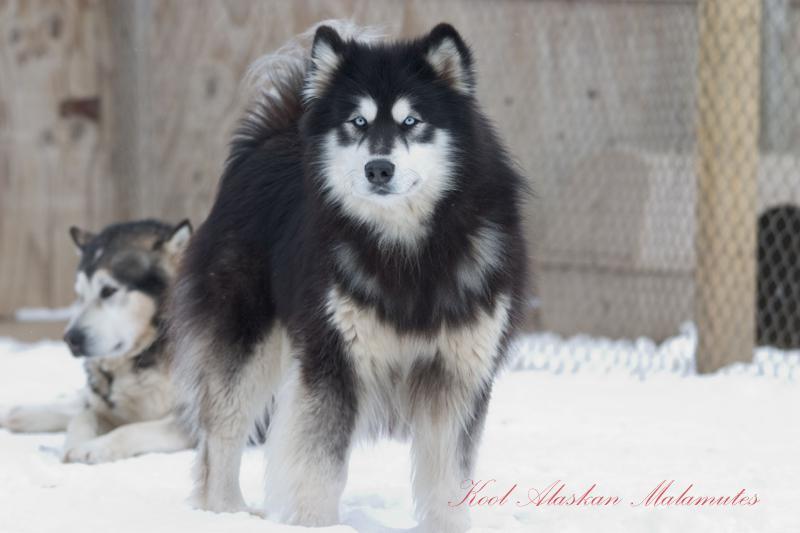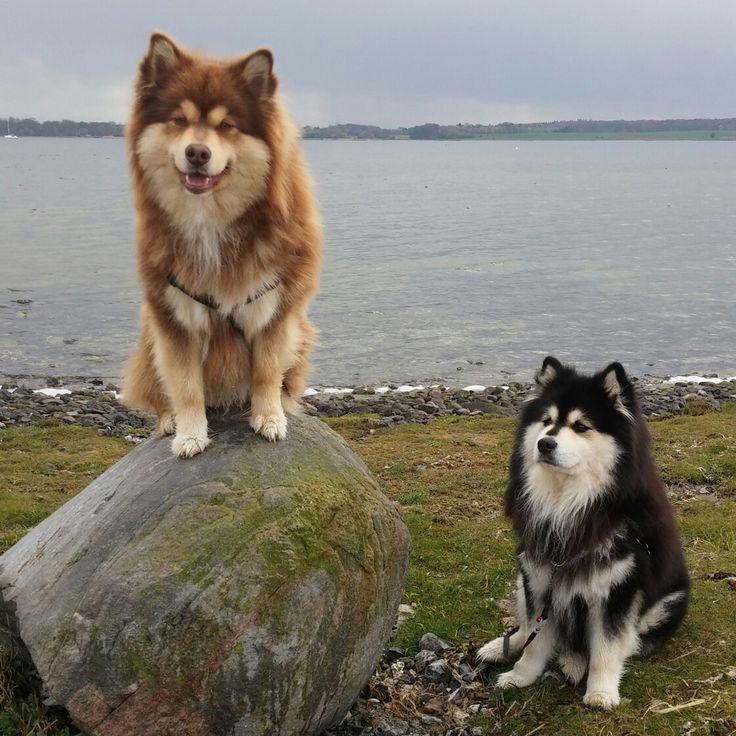The first image is the image on the left, the second image is the image on the right. Assess this claim about the two images: "The left image contains exactly one dog.". Correct or not? Answer yes or no. No. The first image is the image on the left, the second image is the image on the right. Assess this claim about the two images: "One of the images shows a body of water in the background.". Correct or not? Answer yes or no. Yes. 